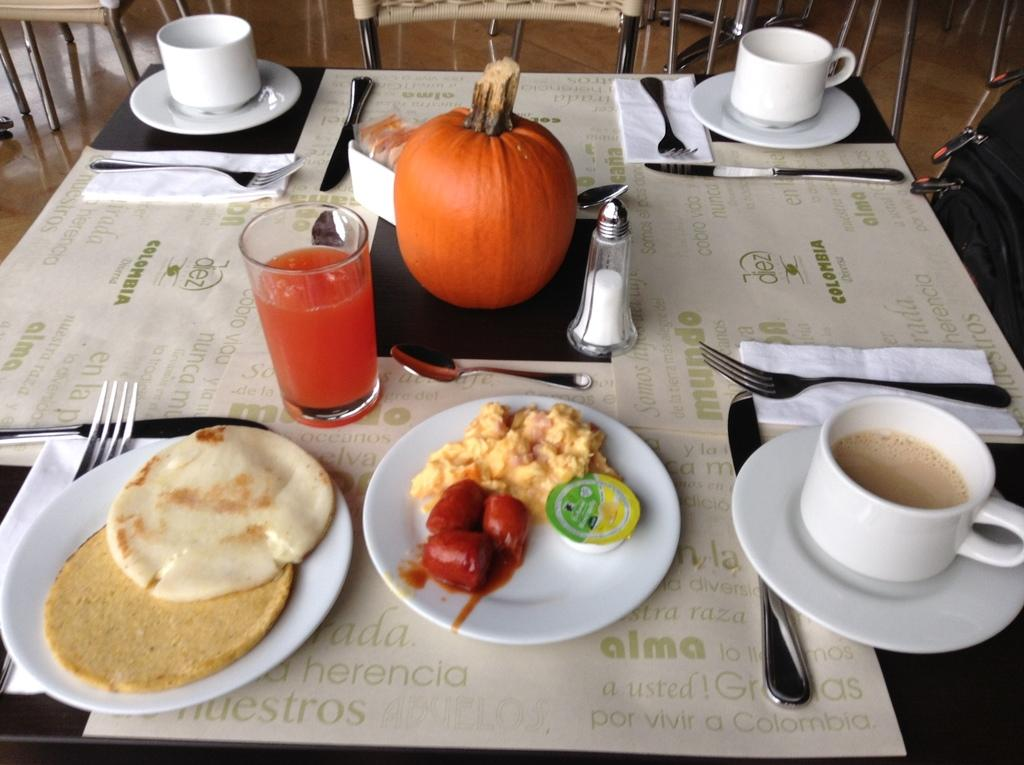What types of tableware can be seen in the image? Cups, plates, forks, and knives are visible in the image. What is the purpose of the glass in the image? The glass is likely used for holding a beverage. What is on the plates in the image? There is food on the plates in the image. What type of furniture is present in the image? Chairs and a table are present in the image. What type of suit is hanging on the wall in the image? There is no suit present in the image. What kind of apparatus is being used to prepare the food in the image? There is no apparatus visible in the image; the food is already on the plates. Is there a jail visible in the image? There is no jail present in the image. 